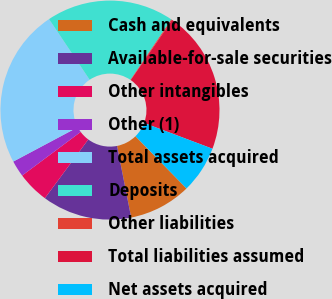<chart> <loc_0><loc_0><loc_500><loc_500><pie_chart><fcel>Cash and equivalents<fcel>Available-for-sale securities<fcel>Other intangibles<fcel>Other (1)<fcel>Total assets acquired<fcel>Deposits<fcel>Other liabilities<fcel>Total liabilities assumed<fcel>Net assets acquired<nl><fcel>9.21%<fcel>13.23%<fcel>4.68%<fcel>2.41%<fcel>23.39%<fcel>18.86%<fcel>0.14%<fcel>21.13%<fcel>6.95%<nl></chart> 